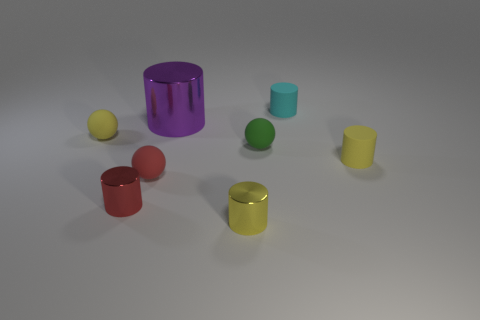How many other things are the same color as the big metal cylinder? There are three smaller cylinders that share the identical purple hue with the large metal cylinder. 